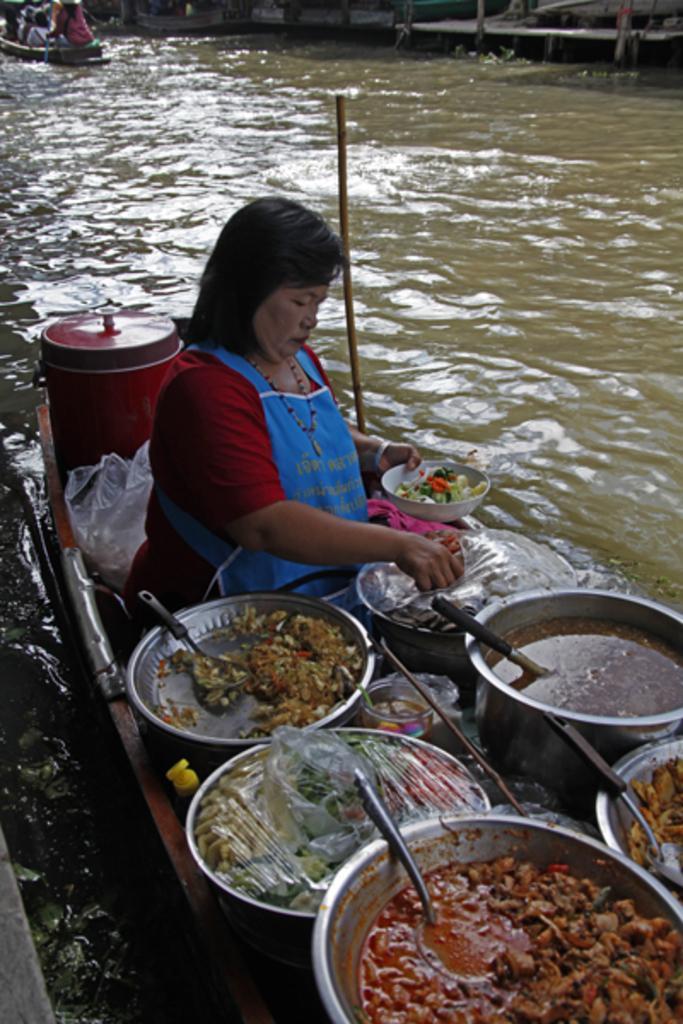How would you summarize this image in a sentence or two? As we can see in the image there is water, boat, few people sitting on boat. The woman sitting over here is holding a bowl and here there are bowls. In these bowl there are food items. 